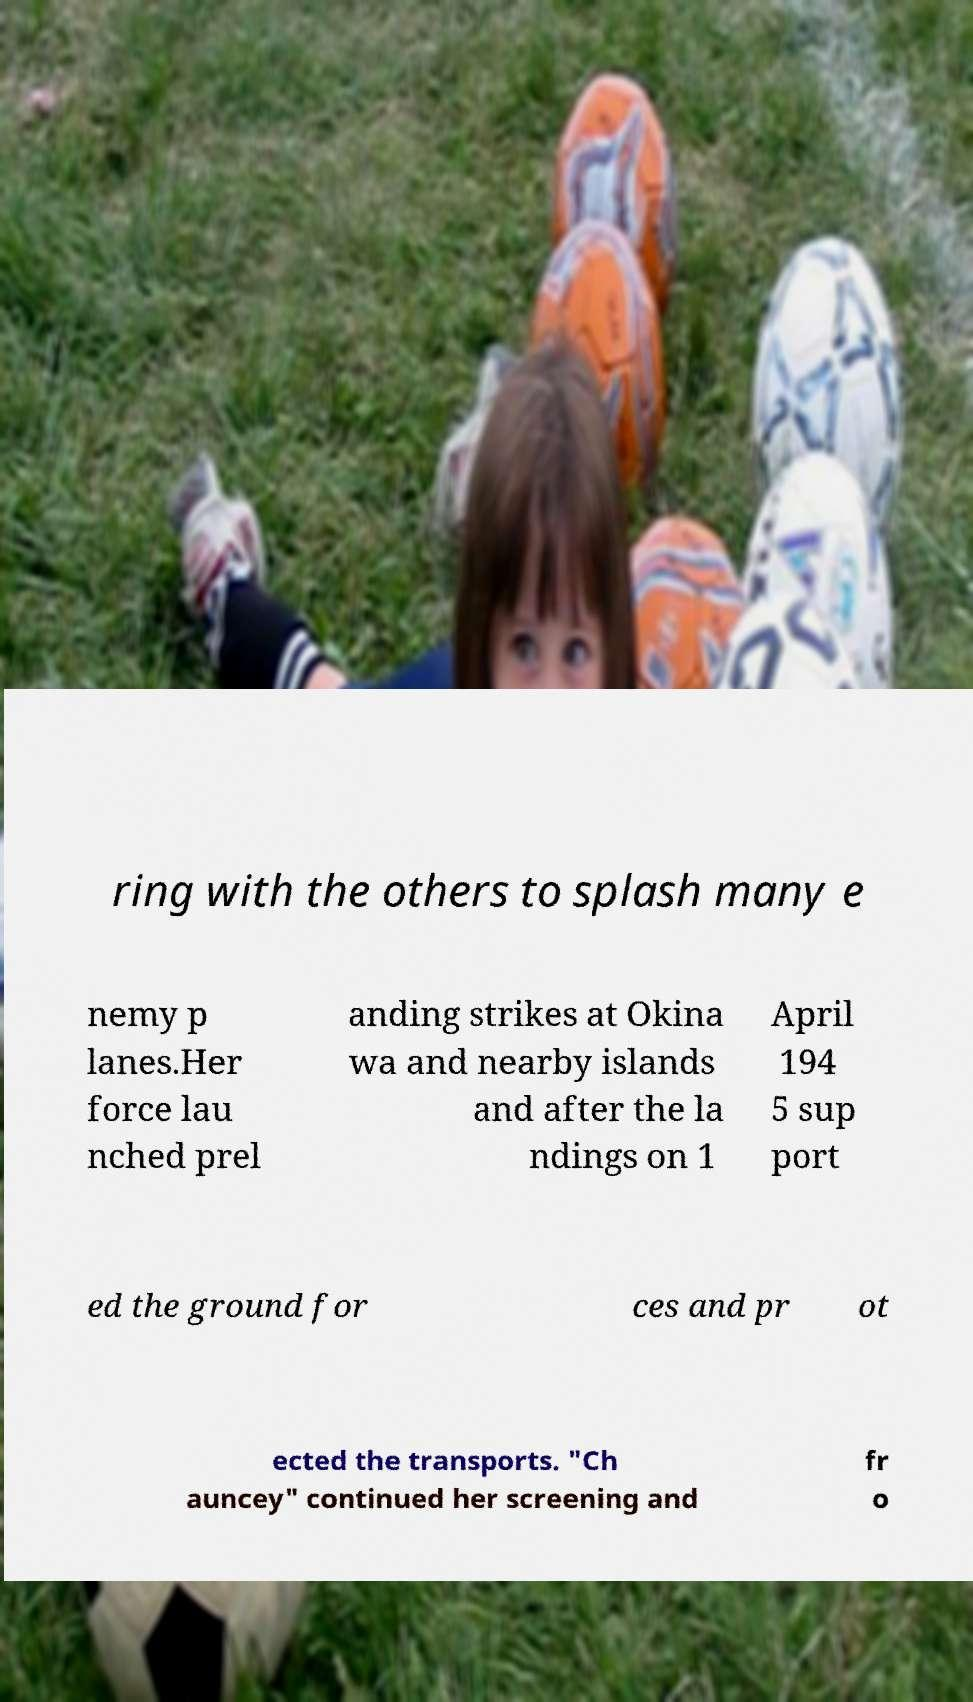There's text embedded in this image that I need extracted. Can you transcribe it verbatim? ring with the others to splash many e nemy p lanes.Her force lau nched prel anding strikes at Okina wa and nearby islands and after the la ndings on 1 April 194 5 sup port ed the ground for ces and pr ot ected the transports. "Ch auncey" continued her screening and fr o 